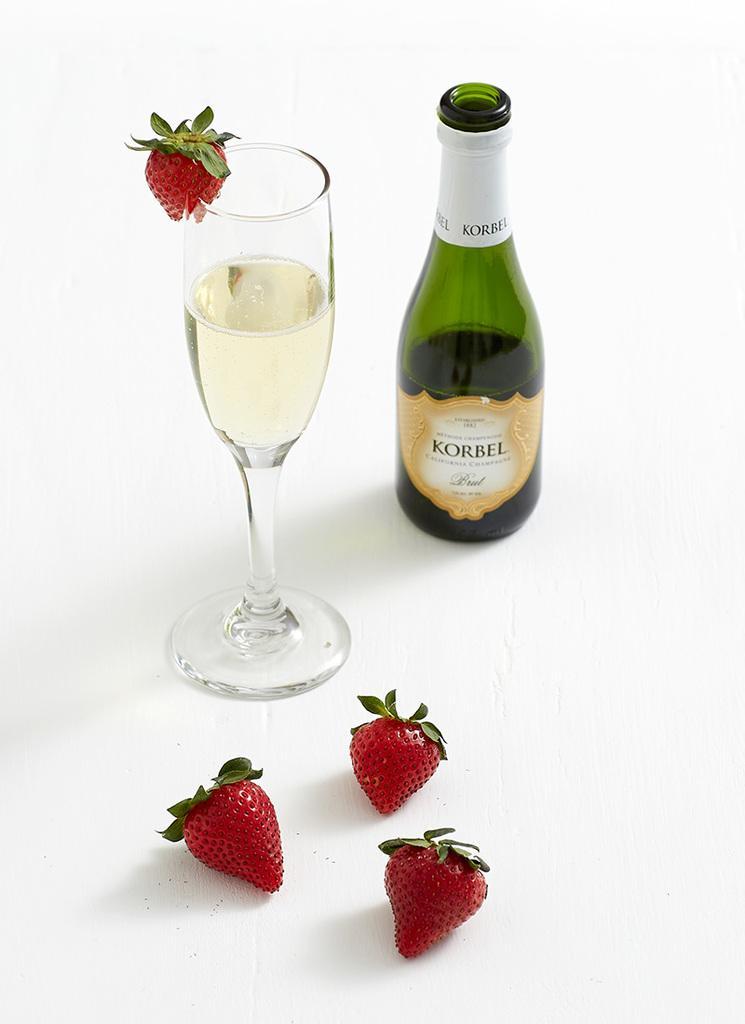How would you summarize this image in a sentence or two? There is a glass of wine,bottle and four strawberries in this image. 